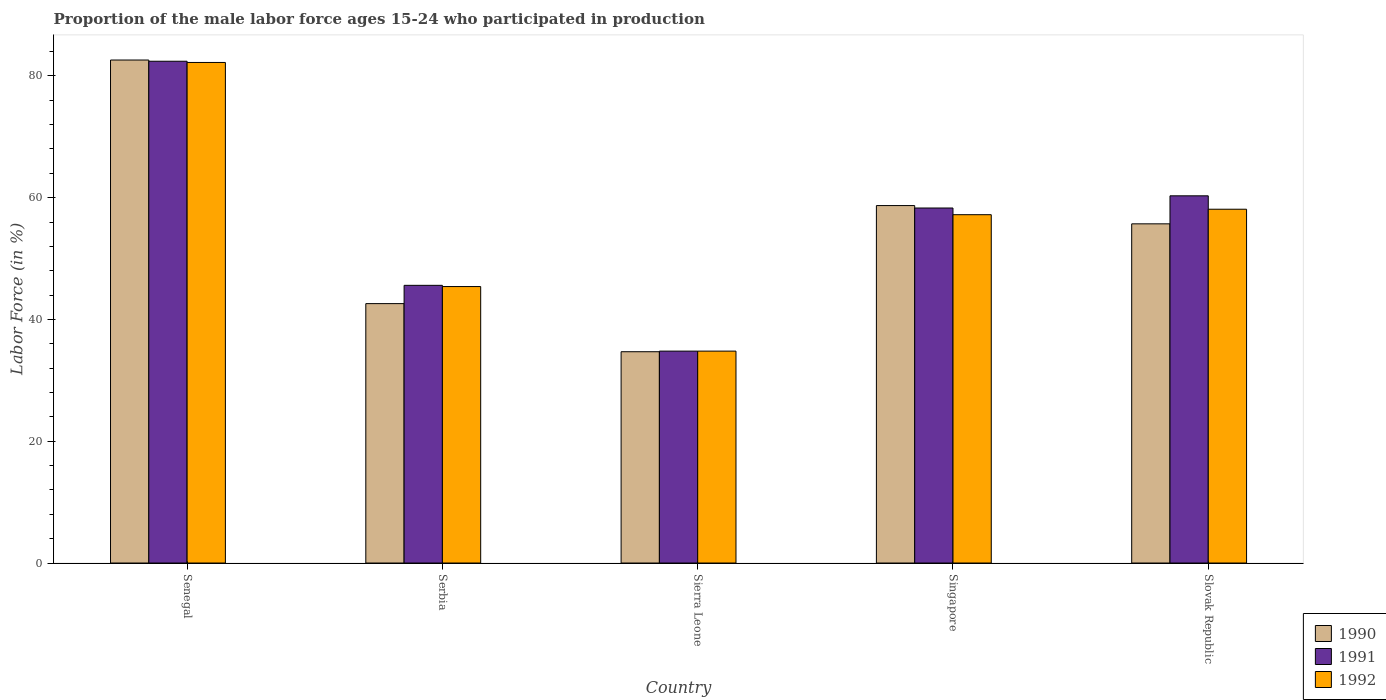How many different coloured bars are there?
Keep it short and to the point. 3. Are the number of bars per tick equal to the number of legend labels?
Your response must be concise. Yes. Are the number of bars on each tick of the X-axis equal?
Give a very brief answer. Yes. What is the label of the 5th group of bars from the left?
Provide a short and direct response. Slovak Republic. In how many cases, is the number of bars for a given country not equal to the number of legend labels?
Your response must be concise. 0. What is the proportion of the male labor force who participated in production in 1990 in Slovak Republic?
Your response must be concise. 55.7. Across all countries, what is the maximum proportion of the male labor force who participated in production in 1992?
Offer a terse response. 82.2. Across all countries, what is the minimum proportion of the male labor force who participated in production in 1991?
Offer a very short reply. 34.8. In which country was the proportion of the male labor force who participated in production in 1991 maximum?
Keep it short and to the point. Senegal. In which country was the proportion of the male labor force who participated in production in 1991 minimum?
Offer a terse response. Sierra Leone. What is the total proportion of the male labor force who participated in production in 1992 in the graph?
Your response must be concise. 277.7. What is the difference between the proportion of the male labor force who participated in production in 1990 in Senegal and that in Singapore?
Make the answer very short. 23.9. What is the difference between the proportion of the male labor force who participated in production in 1992 in Singapore and the proportion of the male labor force who participated in production in 1990 in Senegal?
Give a very brief answer. -25.4. What is the average proportion of the male labor force who participated in production in 1990 per country?
Keep it short and to the point. 54.86. What is the difference between the proportion of the male labor force who participated in production of/in 1991 and proportion of the male labor force who participated in production of/in 1990 in Senegal?
Your answer should be compact. -0.2. In how many countries, is the proportion of the male labor force who participated in production in 1992 greater than 60 %?
Make the answer very short. 1. What is the ratio of the proportion of the male labor force who participated in production in 1992 in Singapore to that in Slovak Republic?
Offer a very short reply. 0.98. Is the difference between the proportion of the male labor force who participated in production in 1991 in Serbia and Sierra Leone greater than the difference between the proportion of the male labor force who participated in production in 1990 in Serbia and Sierra Leone?
Your answer should be very brief. Yes. What is the difference between the highest and the second highest proportion of the male labor force who participated in production in 1990?
Your answer should be very brief. 23.9. What is the difference between the highest and the lowest proportion of the male labor force who participated in production in 1990?
Ensure brevity in your answer.  47.9. Are all the bars in the graph horizontal?
Your answer should be compact. No. What is the difference between two consecutive major ticks on the Y-axis?
Give a very brief answer. 20. Are the values on the major ticks of Y-axis written in scientific E-notation?
Your answer should be compact. No. How many legend labels are there?
Make the answer very short. 3. What is the title of the graph?
Your response must be concise. Proportion of the male labor force ages 15-24 who participated in production. What is the Labor Force (in %) in 1990 in Senegal?
Provide a short and direct response. 82.6. What is the Labor Force (in %) of 1991 in Senegal?
Your response must be concise. 82.4. What is the Labor Force (in %) of 1992 in Senegal?
Your answer should be very brief. 82.2. What is the Labor Force (in %) in 1990 in Serbia?
Provide a succinct answer. 42.6. What is the Labor Force (in %) in 1991 in Serbia?
Ensure brevity in your answer.  45.6. What is the Labor Force (in %) in 1992 in Serbia?
Your answer should be very brief. 45.4. What is the Labor Force (in %) of 1990 in Sierra Leone?
Your response must be concise. 34.7. What is the Labor Force (in %) of 1991 in Sierra Leone?
Your answer should be very brief. 34.8. What is the Labor Force (in %) in 1992 in Sierra Leone?
Offer a very short reply. 34.8. What is the Labor Force (in %) in 1990 in Singapore?
Ensure brevity in your answer.  58.7. What is the Labor Force (in %) of 1991 in Singapore?
Ensure brevity in your answer.  58.3. What is the Labor Force (in %) in 1992 in Singapore?
Ensure brevity in your answer.  57.2. What is the Labor Force (in %) of 1990 in Slovak Republic?
Give a very brief answer. 55.7. What is the Labor Force (in %) of 1991 in Slovak Republic?
Give a very brief answer. 60.3. What is the Labor Force (in %) in 1992 in Slovak Republic?
Keep it short and to the point. 58.1. Across all countries, what is the maximum Labor Force (in %) of 1990?
Provide a short and direct response. 82.6. Across all countries, what is the maximum Labor Force (in %) in 1991?
Your answer should be compact. 82.4. Across all countries, what is the maximum Labor Force (in %) of 1992?
Offer a very short reply. 82.2. Across all countries, what is the minimum Labor Force (in %) of 1990?
Keep it short and to the point. 34.7. Across all countries, what is the minimum Labor Force (in %) of 1991?
Ensure brevity in your answer.  34.8. Across all countries, what is the minimum Labor Force (in %) in 1992?
Your answer should be compact. 34.8. What is the total Labor Force (in %) in 1990 in the graph?
Your answer should be compact. 274.3. What is the total Labor Force (in %) of 1991 in the graph?
Give a very brief answer. 281.4. What is the total Labor Force (in %) of 1992 in the graph?
Offer a very short reply. 277.7. What is the difference between the Labor Force (in %) of 1991 in Senegal and that in Serbia?
Give a very brief answer. 36.8. What is the difference between the Labor Force (in %) in 1992 in Senegal and that in Serbia?
Offer a very short reply. 36.8. What is the difference between the Labor Force (in %) in 1990 in Senegal and that in Sierra Leone?
Offer a terse response. 47.9. What is the difference between the Labor Force (in %) of 1991 in Senegal and that in Sierra Leone?
Keep it short and to the point. 47.6. What is the difference between the Labor Force (in %) of 1992 in Senegal and that in Sierra Leone?
Offer a terse response. 47.4. What is the difference between the Labor Force (in %) of 1990 in Senegal and that in Singapore?
Provide a short and direct response. 23.9. What is the difference between the Labor Force (in %) of 1991 in Senegal and that in Singapore?
Your answer should be very brief. 24.1. What is the difference between the Labor Force (in %) in 1992 in Senegal and that in Singapore?
Offer a terse response. 25. What is the difference between the Labor Force (in %) of 1990 in Senegal and that in Slovak Republic?
Make the answer very short. 26.9. What is the difference between the Labor Force (in %) in 1991 in Senegal and that in Slovak Republic?
Your answer should be very brief. 22.1. What is the difference between the Labor Force (in %) in 1992 in Senegal and that in Slovak Republic?
Your response must be concise. 24.1. What is the difference between the Labor Force (in %) in 1990 in Serbia and that in Sierra Leone?
Make the answer very short. 7.9. What is the difference between the Labor Force (in %) of 1992 in Serbia and that in Sierra Leone?
Provide a succinct answer. 10.6. What is the difference between the Labor Force (in %) of 1990 in Serbia and that in Singapore?
Keep it short and to the point. -16.1. What is the difference between the Labor Force (in %) of 1991 in Serbia and that in Singapore?
Ensure brevity in your answer.  -12.7. What is the difference between the Labor Force (in %) of 1992 in Serbia and that in Singapore?
Your answer should be very brief. -11.8. What is the difference between the Labor Force (in %) of 1990 in Serbia and that in Slovak Republic?
Offer a very short reply. -13.1. What is the difference between the Labor Force (in %) in 1991 in Serbia and that in Slovak Republic?
Keep it short and to the point. -14.7. What is the difference between the Labor Force (in %) of 1990 in Sierra Leone and that in Singapore?
Provide a short and direct response. -24. What is the difference between the Labor Force (in %) in 1991 in Sierra Leone and that in Singapore?
Your response must be concise. -23.5. What is the difference between the Labor Force (in %) of 1992 in Sierra Leone and that in Singapore?
Your response must be concise. -22.4. What is the difference between the Labor Force (in %) in 1990 in Sierra Leone and that in Slovak Republic?
Provide a short and direct response. -21. What is the difference between the Labor Force (in %) of 1991 in Sierra Leone and that in Slovak Republic?
Provide a succinct answer. -25.5. What is the difference between the Labor Force (in %) in 1992 in Sierra Leone and that in Slovak Republic?
Your answer should be very brief. -23.3. What is the difference between the Labor Force (in %) of 1990 in Senegal and the Labor Force (in %) of 1991 in Serbia?
Make the answer very short. 37. What is the difference between the Labor Force (in %) in 1990 in Senegal and the Labor Force (in %) in 1992 in Serbia?
Provide a short and direct response. 37.2. What is the difference between the Labor Force (in %) in 1991 in Senegal and the Labor Force (in %) in 1992 in Serbia?
Your answer should be very brief. 37. What is the difference between the Labor Force (in %) of 1990 in Senegal and the Labor Force (in %) of 1991 in Sierra Leone?
Your response must be concise. 47.8. What is the difference between the Labor Force (in %) of 1990 in Senegal and the Labor Force (in %) of 1992 in Sierra Leone?
Ensure brevity in your answer.  47.8. What is the difference between the Labor Force (in %) of 1991 in Senegal and the Labor Force (in %) of 1992 in Sierra Leone?
Keep it short and to the point. 47.6. What is the difference between the Labor Force (in %) of 1990 in Senegal and the Labor Force (in %) of 1991 in Singapore?
Provide a short and direct response. 24.3. What is the difference between the Labor Force (in %) in 1990 in Senegal and the Labor Force (in %) in 1992 in Singapore?
Your response must be concise. 25.4. What is the difference between the Labor Force (in %) of 1991 in Senegal and the Labor Force (in %) of 1992 in Singapore?
Your response must be concise. 25.2. What is the difference between the Labor Force (in %) of 1990 in Senegal and the Labor Force (in %) of 1991 in Slovak Republic?
Your answer should be compact. 22.3. What is the difference between the Labor Force (in %) in 1990 in Senegal and the Labor Force (in %) in 1992 in Slovak Republic?
Keep it short and to the point. 24.5. What is the difference between the Labor Force (in %) of 1991 in Senegal and the Labor Force (in %) of 1992 in Slovak Republic?
Provide a short and direct response. 24.3. What is the difference between the Labor Force (in %) in 1990 in Serbia and the Labor Force (in %) in 1991 in Sierra Leone?
Keep it short and to the point. 7.8. What is the difference between the Labor Force (in %) in 1990 in Serbia and the Labor Force (in %) in 1991 in Singapore?
Provide a succinct answer. -15.7. What is the difference between the Labor Force (in %) of 1990 in Serbia and the Labor Force (in %) of 1992 in Singapore?
Your response must be concise. -14.6. What is the difference between the Labor Force (in %) in 1991 in Serbia and the Labor Force (in %) in 1992 in Singapore?
Give a very brief answer. -11.6. What is the difference between the Labor Force (in %) in 1990 in Serbia and the Labor Force (in %) in 1991 in Slovak Republic?
Make the answer very short. -17.7. What is the difference between the Labor Force (in %) in 1990 in Serbia and the Labor Force (in %) in 1992 in Slovak Republic?
Offer a terse response. -15.5. What is the difference between the Labor Force (in %) of 1991 in Serbia and the Labor Force (in %) of 1992 in Slovak Republic?
Your answer should be compact. -12.5. What is the difference between the Labor Force (in %) in 1990 in Sierra Leone and the Labor Force (in %) in 1991 in Singapore?
Your answer should be very brief. -23.6. What is the difference between the Labor Force (in %) of 1990 in Sierra Leone and the Labor Force (in %) of 1992 in Singapore?
Provide a succinct answer. -22.5. What is the difference between the Labor Force (in %) of 1991 in Sierra Leone and the Labor Force (in %) of 1992 in Singapore?
Make the answer very short. -22.4. What is the difference between the Labor Force (in %) of 1990 in Sierra Leone and the Labor Force (in %) of 1991 in Slovak Republic?
Provide a succinct answer. -25.6. What is the difference between the Labor Force (in %) in 1990 in Sierra Leone and the Labor Force (in %) in 1992 in Slovak Republic?
Give a very brief answer. -23.4. What is the difference between the Labor Force (in %) of 1991 in Sierra Leone and the Labor Force (in %) of 1992 in Slovak Republic?
Provide a short and direct response. -23.3. What is the difference between the Labor Force (in %) of 1990 in Singapore and the Labor Force (in %) of 1991 in Slovak Republic?
Provide a short and direct response. -1.6. What is the difference between the Labor Force (in %) of 1990 in Singapore and the Labor Force (in %) of 1992 in Slovak Republic?
Your answer should be compact. 0.6. What is the difference between the Labor Force (in %) of 1991 in Singapore and the Labor Force (in %) of 1992 in Slovak Republic?
Offer a very short reply. 0.2. What is the average Labor Force (in %) of 1990 per country?
Your answer should be very brief. 54.86. What is the average Labor Force (in %) in 1991 per country?
Your response must be concise. 56.28. What is the average Labor Force (in %) in 1992 per country?
Offer a terse response. 55.54. What is the difference between the Labor Force (in %) of 1990 and Labor Force (in %) of 1991 in Serbia?
Provide a short and direct response. -3. What is the difference between the Labor Force (in %) in 1990 and Labor Force (in %) in 1992 in Sierra Leone?
Your response must be concise. -0.1. What is the difference between the Labor Force (in %) in 1991 and Labor Force (in %) in 1992 in Sierra Leone?
Your answer should be very brief. 0. What is the difference between the Labor Force (in %) in 1990 and Labor Force (in %) in 1992 in Singapore?
Ensure brevity in your answer.  1.5. What is the difference between the Labor Force (in %) of 1991 and Labor Force (in %) of 1992 in Singapore?
Your answer should be compact. 1.1. What is the difference between the Labor Force (in %) in 1990 and Labor Force (in %) in 1991 in Slovak Republic?
Make the answer very short. -4.6. What is the difference between the Labor Force (in %) in 1990 and Labor Force (in %) in 1992 in Slovak Republic?
Your answer should be very brief. -2.4. What is the ratio of the Labor Force (in %) in 1990 in Senegal to that in Serbia?
Keep it short and to the point. 1.94. What is the ratio of the Labor Force (in %) in 1991 in Senegal to that in Serbia?
Keep it short and to the point. 1.81. What is the ratio of the Labor Force (in %) in 1992 in Senegal to that in Serbia?
Make the answer very short. 1.81. What is the ratio of the Labor Force (in %) in 1990 in Senegal to that in Sierra Leone?
Ensure brevity in your answer.  2.38. What is the ratio of the Labor Force (in %) of 1991 in Senegal to that in Sierra Leone?
Provide a short and direct response. 2.37. What is the ratio of the Labor Force (in %) of 1992 in Senegal to that in Sierra Leone?
Offer a very short reply. 2.36. What is the ratio of the Labor Force (in %) in 1990 in Senegal to that in Singapore?
Make the answer very short. 1.41. What is the ratio of the Labor Force (in %) of 1991 in Senegal to that in Singapore?
Your answer should be very brief. 1.41. What is the ratio of the Labor Force (in %) in 1992 in Senegal to that in Singapore?
Offer a very short reply. 1.44. What is the ratio of the Labor Force (in %) in 1990 in Senegal to that in Slovak Republic?
Your answer should be very brief. 1.48. What is the ratio of the Labor Force (in %) in 1991 in Senegal to that in Slovak Republic?
Keep it short and to the point. 1.37. What is the ratio of the Labor Force (in %) in 1992 in Senegal to that in Slovak Republic?
Give a very brief answer. 1.41. What is the ratio of the Labor Force (in %) in 1990 in Serbia to that in Sierra Leone?
Provide a succinct answer. 1.23. What is the ratio of the Labor Force (in %) of 1991 in Serbia to that in Sierra Leone?
Your answer should be compact. 1.31. What is the ratio of the Labor Force (in %) of 1992 in Serbia to that in Sierra Leone?
Your response must be concise. 1.3. What is the ratio of the Labor Force (in %) in 1990 in Serbia to that in Singapore?
Your answer should be compact. 0.73. What is the ratio of the Labor Force (in %) of 1991 in Serbia to that in Singapore?
Your answer should be compact. 0.78. What is the ratio of the Labor Force (in %) of 1992 in Serbia to that in Singapore?
Provide a short and direct response. 0.79. What is the ratio of the Labor Force (in %) of 1990 in Serbia to that in Slovak Republic?
Ensure brevity in your answer.  0.76. What is the ratio of the Labor Force (in %) in 1991 in Serbia to that in Slovak Republic?
Your answer should be compact. 0.76. What is the ratio of the Labor Force (in %) in 1992 in Serbia to that in Slovak Republic?
Keep it short and to the point. 0.78. What is the ratio of the Labor Force (in %) in 1990 in Sierra Leone to that in Singapore?
Your response must be concise. 0.59. What is the ratio of the Labor Force (in %) of 1991 in Sierra Leone to that in Singapore?
Ensure brevity in your answer.  0.6. What is the ratio of the Labor Force (in %) of 1992 in Sierra Leone to that in Singapore?
Your response must be concise. 0.61. What is the ratio of the Labor Force (in %) in 1990 in Sierra Leone to that in Slovak Republic?
Offer a terse response. 0.62. What is the ratio of the Labor Force (in %) in 1991 in Sierra Leone to that in Slovak Republic?
Ensure brevity in your answer.  0.58. What is the ratio of the Labor Force (in %) in 1992 in Sierra Leone to that in Slovak Republic?
Your response must be concise. 0.6. What is the ratio of the Labor Force (in %) in 1990 in Singapore to that in Slovak Republic?
Offer a terse response. 1.05. What is the ratio of the Labor Force (in %) in 1991 in Singapore to that in Slovak Republic?
Keep it short and to the point. 0.97. What is the ratio of the Labor Force (in %) of 1992 in Singapore to that in Slovak Republic?
Keep it short and to the point. 0.98. What is the difference between the highest and the second highest Labor Force (in %) in 1990?
Ensure brevity in your answer.  23.9. What is the difference between the highest and the second highest Labor Force (in %) of 1991?
Offer a very short reply. 22.1. What is the difference between the highest and the second highest Labor Force (in %) of 1992?
Your response must be concise. 24.1. What is the difference between the highest and the lowest Labor Force (in %) of 1990?
Provide a succinct answer. 47.9. What is the difference between the highest and the lowest Labor Force (in %) in 1991?
Your answer should be compact. 47.6. What is the difference between the highest and the lowest Labor Force (in %) in 1992?
Make the answer very short. 47.4. 